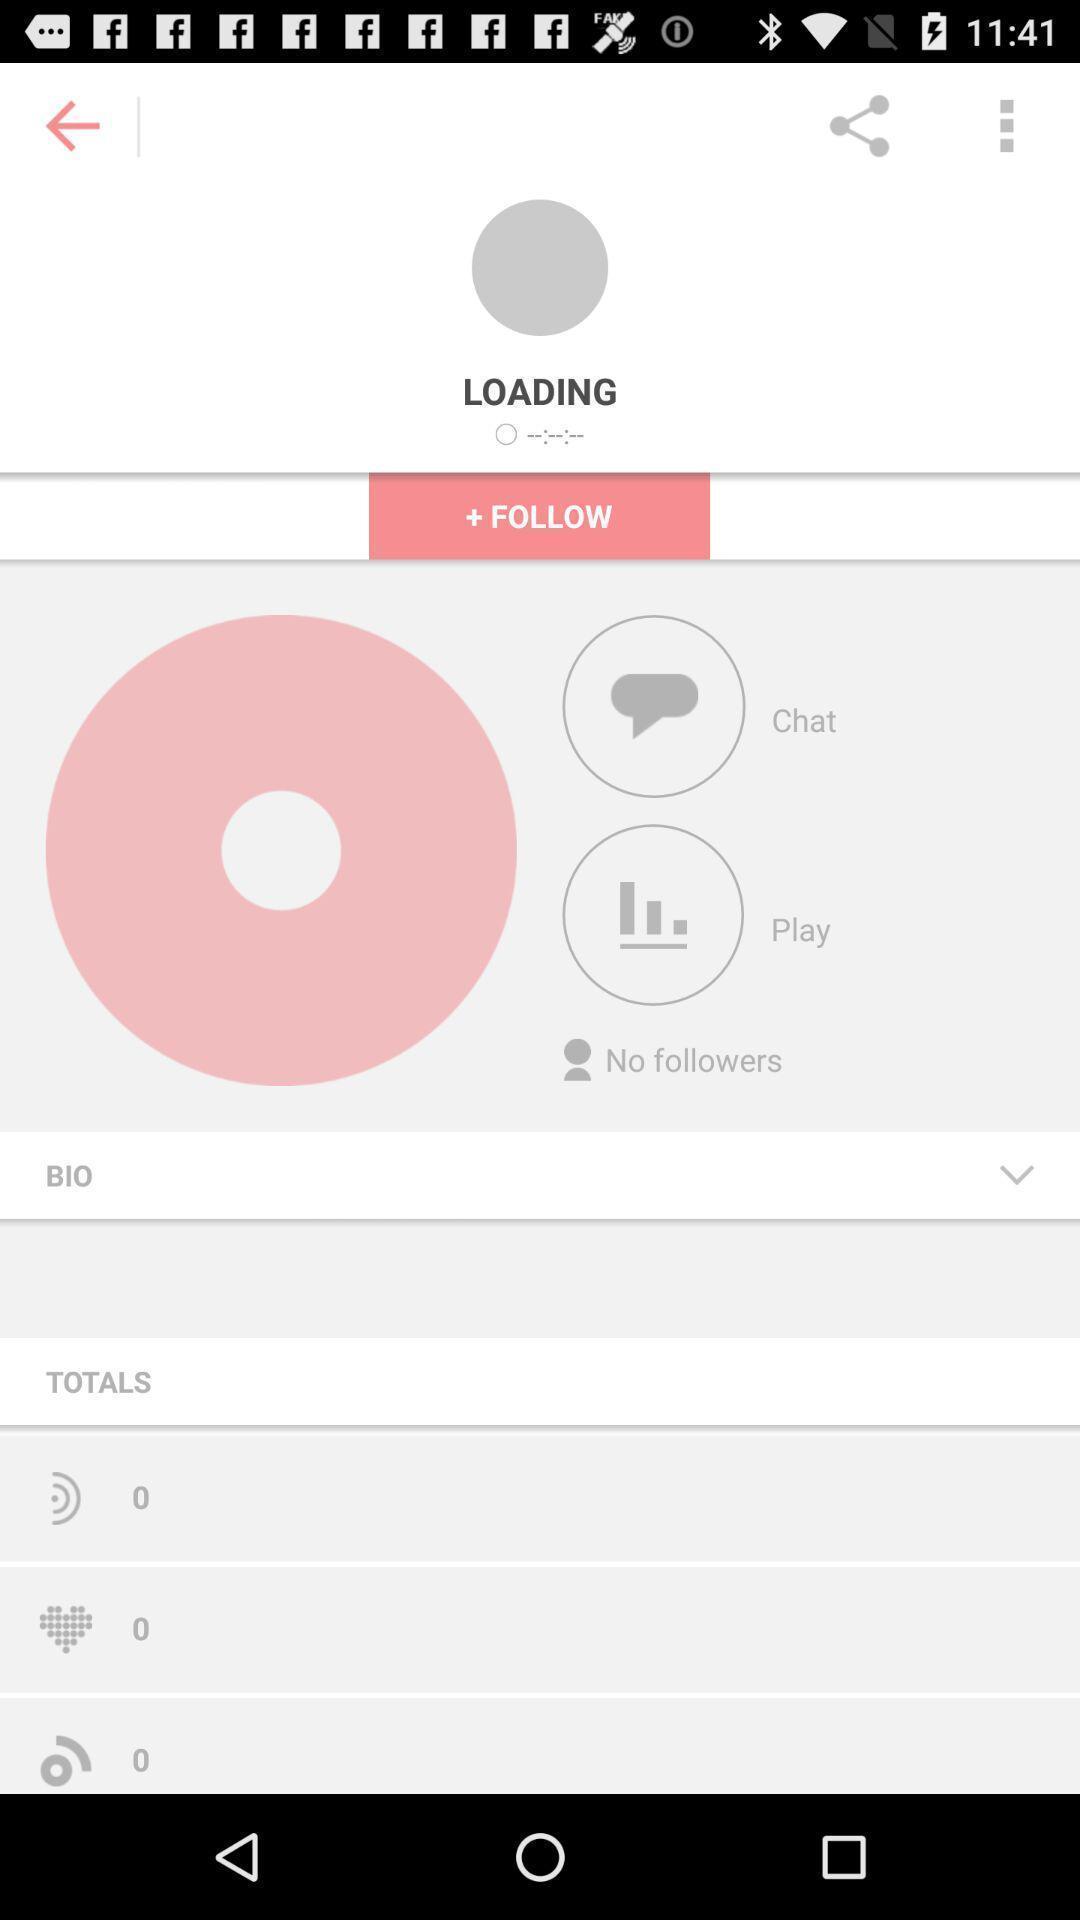Give me a summary of this screen capture. Screen showing account details of a social media. 